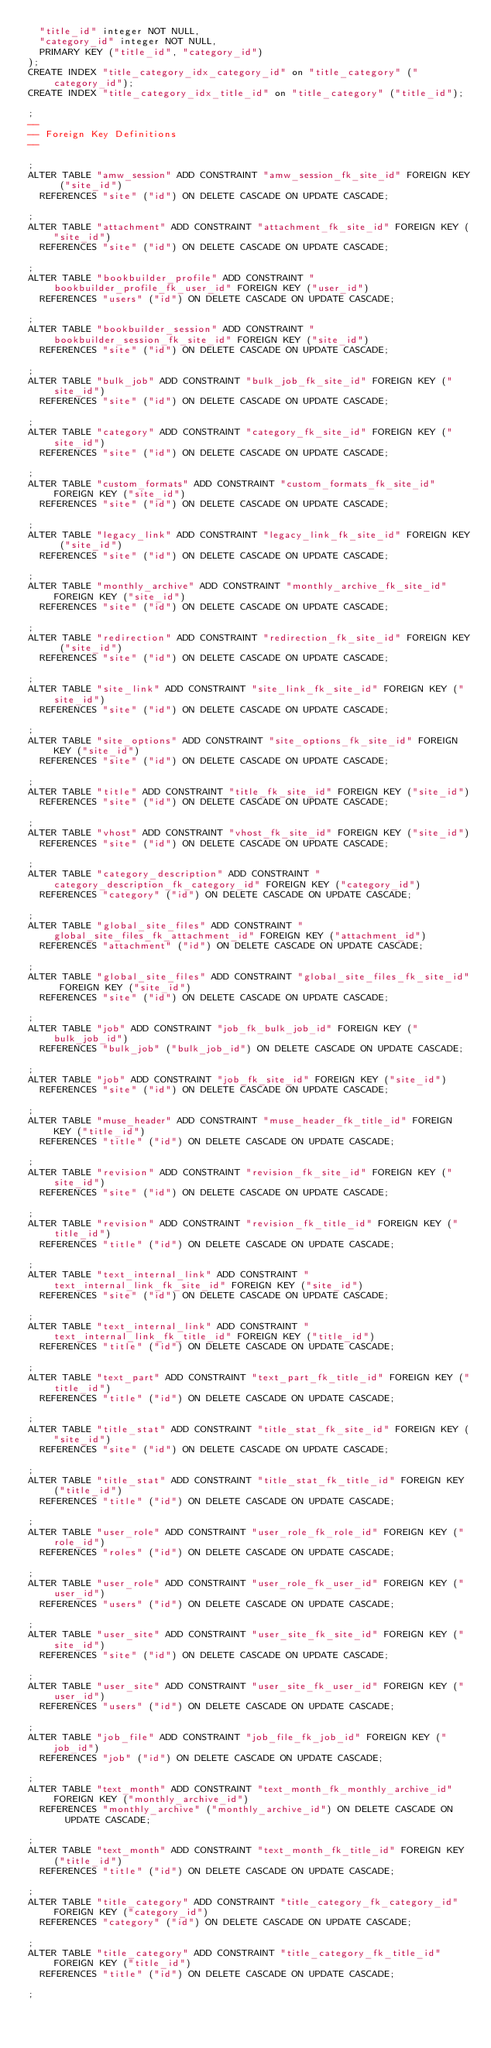<code> <loc_0><loc_0><loc_500><loc_500><_SQL_>  "title_id" integer NOT NULL,
  "category_id" integer NOT NULL,
  PRIMARY KEY ("title_id", "category_id")
);
CREATE INDEX "title_category_idx_category_id" on "title_category" ("category_id");
CREATE INDEX "title_category_idx_title_id" on "title_category" ("title_id");

;
--
-- Foreign Key Definitions
--

;
ALTER TABLE "amw_session" ADD CONSTRAINT "amw_session_fk_site_id" FOREIGN KEY ("site_id")
  REFERENCES "site" ("id") ON DELETE CASCADE ON UPDATE CASCADE;

;
ALTER TABLE "attachment" ADD CONSTRAINT "attachment_fk_site_id" FOREIGN KEY ("site_id")
  REFERENCES "site" ("id") ON DELETE CASCADE ON UPDATE CASCADE;

;
ALTER TABLE "bookbuilder_profile" ADD CONSTRAINT "bookbuilder_profile_fk_user_id" FOREIGN KEY ("user_id")
  REFERENCES "users" ("id") ON DELETE CASCADE ON UPDATE CASCADE;

;
ALTER TABLE "bookbuilder_session" ADD CONSTRAINT "bookbuilder_session_fk_site_id" FOREIGN KEY ("site_id")
  REFERENCES "site" ("id") ON DELETE CASCADE ON UPDATE CASCADE;

;
ALTER TABLE "bulk_job" ADD CONSTRAINT "bulk_job_fk_site_id" FOREIGN KEY ("site_id")
  REFERENCES "site" ("id") ON DELETE CASCADE ON UPDATE CASCADE;

;
ALTER TABLE "category" ADD CONSTRAINT "category_fk_site_id" FOREIGN KEY ("site_id")
  REFERENCES "site" ("id") ON DELETE CASCADE ON UPDATE CASCADE;

;
ALTER TABLE "custom_formats" ADD CONSTRAINT "custom_formats_fk_site_id" FOREIGN KEY ("site_id")
  REFERENCES "site" ("id") ON DELETE CASCADE ON UPDATE CASCADE;

;
ALTER TABLE "legacy_link" ADD CONSTRAINT "legacy_link_fk_site_id" FOREIGN KEY ("site_id")
  REFERENCES "site" ("id") ON DELETE CASCADE ON UPDATE CASCADE;

;
ALTER TABLE "monthly_archive" ADD CONSTRAINT "monthly_archive_fk_site_id" FOREIGN KEY ("site_id")
  REFERENCES "site" ("id") ON DELETE CASCADE ON UPDATE CASCADE;

;
ALTER TABLE "redirection" ADD CONSTRAINT "redirection_fk_site_id" FOREIGN KEY ("site_id")
  REFERENCES "site" ("id") ON DELETE CASCADE ON UPDATE CASCADE;

;
ALTER TABLE "site_link" ADD CONSTRAINT "site_link_fk_site_id" FOREIGN KEY ("site_id")
  REFERENCES "site" ("id") ON DELETE CASCADE ON UPDATE CASCADE;

;
ALTER TABLE "site_options" ADD CONSTRAINT "site_options_fk_site_id" FOREIGN KEY ("site_id")
  REFERENCES "site" ("id") ON DELETE CASCADE ON UPDATE CASCADE;

;
ALTER TABLE "title" ADD CONSTRAINT "title_fk_site_id" FOREIGN KEY ("site_id")
  REFERENCES "site" ("id") ON DELETE CASCADE ON UPDATE CASCADE;

;
ALTER TABLE "vhost" ADD CONSTRAINT "vhost_fk_site_id" FOREIGN KEY ("site_id")
  REFERENCES "site" ("id") ON DELETE CASCADE ON UPDATE CASCADE;

;
ALTER TABLE "category_description" ADD CONSTRAINT "category_description_fk_category_id" FOREIGN KEY ("category_id")
  REFERENCES "category" ("id") ON DELETE CASCADE ON UPDATE CASCADE;

;
ALTER TABLE "global_site_files" ADD CONSTRAINT "global_site_files_fk_attachment_id" FOREIGN KEY ("attachment_id")
  REFERENCES "attachment" ("id") ON DELETE CASCADE ON UPDATE CASCADE;

;
ALTER TABLE "global_site_files" ADD CONSTRAINT "global_site_files_fk_site_id" FOREIGN KEY ("site_id")
  REFERENCES "site" ("id") ON DELETE CASCADE ON UPDATE CASCADE;

;
ALTER TABLE "job" ADD CONSTRAINT "job_fk_bulk_job_id" FOREIGN KEY ("bulk_job_id")
  REFERENCES "bulk_job" ("bulk_job_id") ON DELETE CASCADE ON UPDATE CASCADE;

;
ALTER TABLE "job" ADD CONSTRAINT "job_fk_site_id" FOREIGN KEY ("site_id")
  REFERENCES "site" ("id") ON DELETE CASCADE ON UPDATE CASCADE;

;
ALTER TABLE "muse_header" ADD CONSTRAINT "muse_header_fk_title_id" FOREIGN KEY ("title_id")
  REFERENCES "title" ("id") ON DELETE CASCADE ON UPDATE CASCADE;

;
ALTER TABLE "revision" ADD CONSTRAINT "revision_fk_site_id" FOREIGN KEY ("site_id")
  REFERENCES "site" ("id") ON DELETE CASCADE ON UPDATE CASCADE;

;
ALTER TABLE "revision" ADD CONSTRAINT "revision_fk_title_id" FOREIGN KEY ("title_id")
  REFERENCES "title" ("id") ON DELETE CASCADE ON UPDATE CASCADE;

;
ALTER TABLE "text_internal_link" ADD CONSTRAINT "text_internal_link_fk_site_id" FOREIGN KEY ("site_id")
  REFERENCES "site" ("id") ON DELETE CASCADE ON UPDATE CASCADE;

;
ALTER TABLE "text_internal_link" ADD CONSTRAINT "text_internal_link_fk_title_id" FOREIGN KEY ("title_id")
  REFERENCES "title" ("id") ON DELETE CASCADE ON UPDATE CASCADE;

;
ALTER TABLE "text_part" ADD CONSTRAINT "text_part_fk_title_id" FOREIGN KEY ("title_id")
  REFERENCES "title" ("id") ON DELETE CASCADE ON UPDATE CASCADE;

;
ALTER TABLE "title_stat" ADD CONSTRAINT "title_stat_fk_site_id" FOREIGN KEY ("site_id")
  REFERENCES "site" ("id") ON DELETE CASCADE ON UPDATE CASCADE;

;
ALTER TABLE "title_stat" ADD CONSTRAINT "title_stat_fk_title_id" FOREIGN KEY ("title_id")
  REFERENCES "title" ("id") ON DELETE CASCADE ON UPDATE CASCADE;

;
ALTER TABLE "user_role" ADD CONSTRAINT "user_role_fk_role_id" FOREIGN KEY ("role_id")
  REFERENCES "roles" ("id") ON DELETE CASCADE ON UPDATE CASCADE;

;
ALTER TABLE "user_role" ADD CONSTRAINT "user_role_fk_user_id" FOREIGN KEY ("user_id")
  REFERENCES "users" ("id") ON DELETE CASCADE ON UPDATE CASCADE;

;
ALTER TABLE "user_site" ADD CONSTRAINT "user_site_fk_site_id" FOREIGN KEY ("site_id")
  REFERENCES "site" ("id") ON DELETE CASCADE ON UPDATE CASCADE;

;
ALTER TABLE "user_site" ADD CONSTRAINT "user_site_fk_user_id" FOREIGN KEY ("user_id")
  REFERENCES "users" ("id") ON DELETE CASCADE ON UPDATE CASCADE;

;
ALTER TABLE "job_file" ADD CONSTRAINT "job_file_fk_job_id" FOREIGN KEY ("job_id")
  REFERENCES "job" ("id") ON DELETE CASCADE ON UPDATE CASCADE;

;
ALTER TABLE "text_month" ADD CONSTRAINT "text_month_fk_monthly_archive_id" FOREIGN KEY ("monthly_archive_id")
  REFERENCES "monthly_archive" ("monthly_archive_id") ON DELETE CASCADE ON UPDATE CASCADE;

;
ALTER TABLE "text_month" ADD CONSTRAINT "text_month_fk_title_id" FOREIGN KEY ("title_id")
  REFERENCES "title" ("id") ON DELETE CASCADE ON UPDATE CASCADE;

;
ALTER TABLE "title_category" ADD CONSTRAINT "title_category_fk_category_id" FOREIGN KEY ("category_id")
  REFERENCES "category" ("id") ON DELETE CASCADE ON UPDATE CASCADE;

;
ALTER TABLE "title_category" ADD CONSTRAINT "title_category_fk_title_id" FOREIGN KEY ("title_id")
  REFERENCES "title" ("id") ON DELETE CASCADE ON UPDATE CASCADE;

;
</code> 